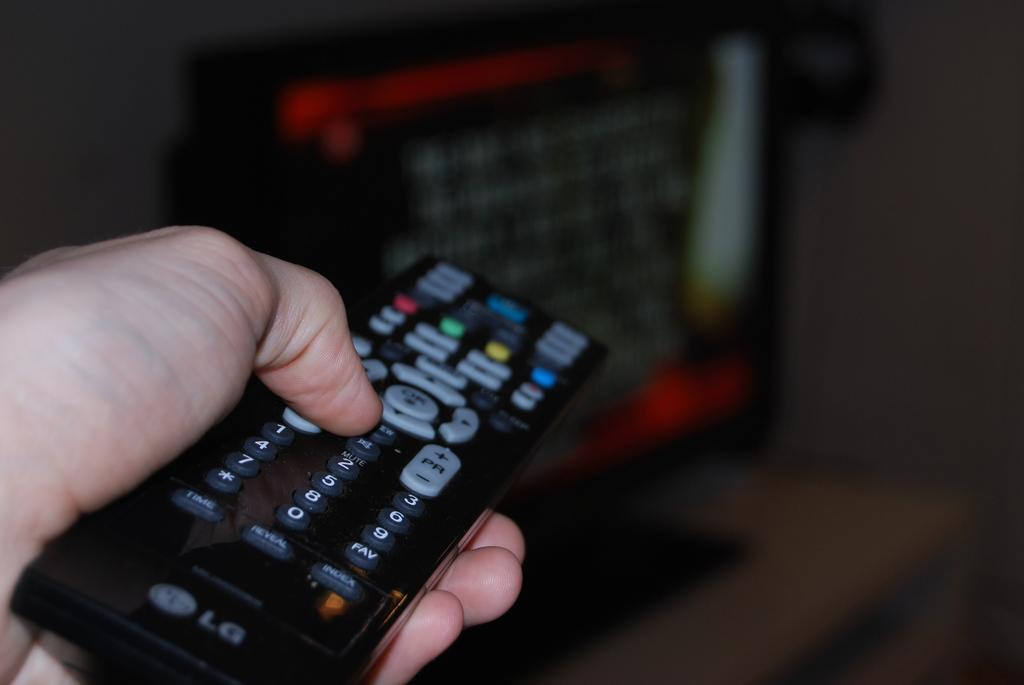<image>
Describe the image concisely. A hand holds an LG remote with a full 10 key numeric pad, a button that says PFI, and others. 